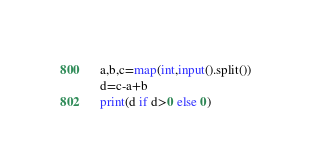<code> <loc_0><loc_0><loc_500><loc_500><_Python_>a,b,c=map(int,input().split())
d=c-a+b
print(d if d>0 else 0)
</code> 